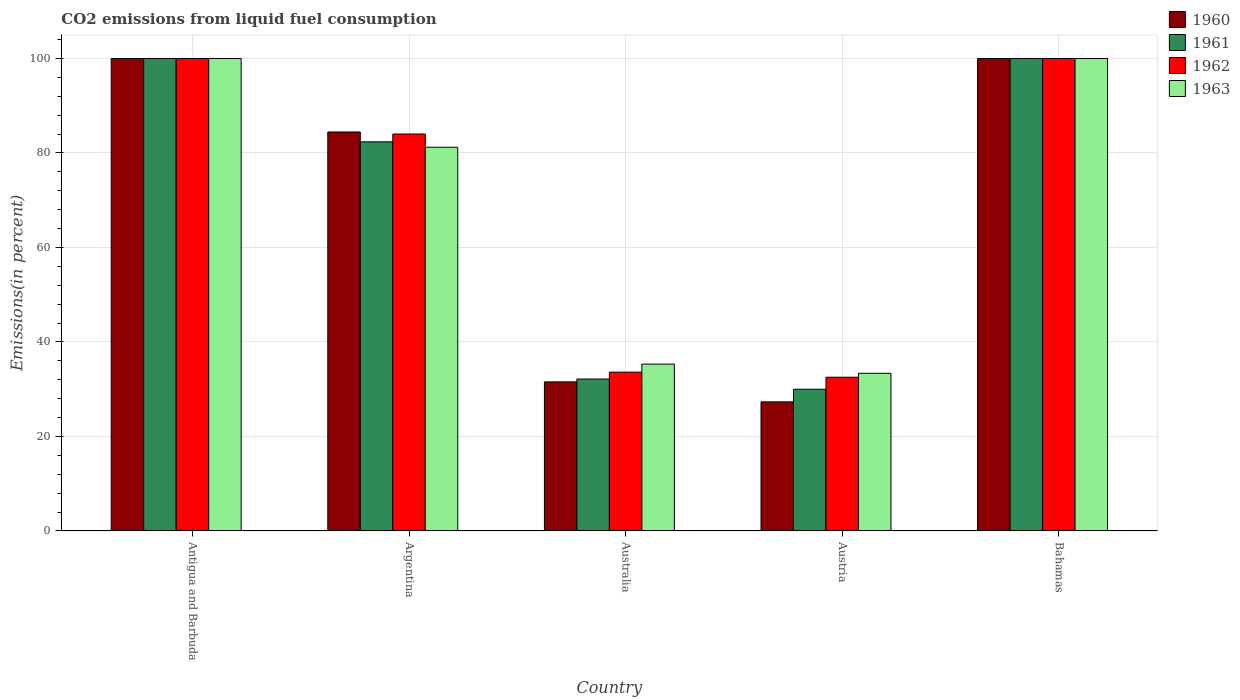Are the number of bars per tick equal to the number of legend labels?
Your answer should be very brief. Yes. Are the number of bars on each tick of the X-axis equal?
Provide a succinct answer. Yes. How many bars are there on the 3rd tick from the left?
Ensure brevity in your answer.  4. What is the total CO2 emitted in 1960 in Argentina?
Your answer should be very brief. 84.45. Across all countries, what is the minimum total CO2 emitted in 1963?
Make the answer very short. 33.38. In which country was the total CO2 emitted in 1961 maximum?
Your response must be concise. Antigua and Barbuda. What is the total total CO2 emitted in 1962 in the graph?
Offer a terse response. 350.18. What is the difference between the total CO2 emitted in 1961 in Antigua and Barbuda and that in Argentina?
Your answer should be compact. 17.63. What is the difference between the total CO2 emitted in 1962 in Australia and the total CO2 emitted in 1960 in Bahamas?
Your response must be concise. -66.38. What is the average total CO2 emitted in 1961 per country?
Keep it short and to the point. 68.91. What is the difference between the total CO2 emitted of/in 1961 and total CO2 emitted of/in 1962 in Argentina?
Provide a short and direct response. -1.65. What is the ratio of the total CO2 emitted in 1963 in Argentina to that in Austria?
Make the answer very short. 2.43. What is the difference between the highest and the second highest total CO2 emitted in 1960?
Your response must be concise. 15.55. What is the difference between the highest and the lowest total CO2 emitted in 1960?
Your response must be concise. 72.67. In how many countries, is the total CO2 emitted in 1960 greater than the average total CO2 emitted in 1960 taken over all countries?
Your answer should be compact. 3. What does the 4th bar from the left in Australia represents?
Your response must be concise. 1963. What does the 2nd bar from the right in Australia represents?
Offer a terse response. 1962. Is it the case that in every country, the sum of the total CO2 emitted in 1960 and total CO2 emitted in 1962 is greater than the total CO2 emitted in 1963?
Offer a terse response. Yes. How many bars are there?
Offer a terse response. 20. Are all the bars in the graph horizontal?
Give a very brief answer. No. What is the difference between two consecutive major ticks on the Y-axis?
Provide a short and direct response. 20. Does the graph contain grids?
Your answer should be very brief. Yes. What is the title of the graph?
Provide a short and direct response. CO2 emissions from liquid fuel consumption. What is the label or title of the Y-axis?
Your response must be concise. Emissions(in percent). What is the Emissions(in percent) in 1960 in Antigua and Barbuda?
Make the answer very short. 100. What is the Emissions(in percent) of 1960 in Argentina?
Keep it short and to the point. 84.45. What is the Emissions(in percent) in 1961 in Argentina?
Your response must be concise. 82.37. What is the Emissions(in percent) in 1962 in Argentina?
Keep it short and to the point. 84.02. What is the Emissions(in percent) of 1963 in Argentina?
Offer a terse response. 81.22. What is the Emissions(in percent) in 1960 in Australia?
Give a very brief answer. 31.56. What is the Emissions(in percent) of 1961 in Australia?
Your response must be concise. 32.16. What is the Emissions(in percent) of 1962 in Australia?
Offer a terse response. 33.62. What is the Emissions(in percent) in 1963 in Australia?
Provide a succinct answer. 35.32. What is the Emissions(in percent) in 1960 in Austria?
Make the answer very short. 27.33. What is the Emissions(in percent) of 1961 in Austria?
Your answer should be very brief. 30. What is the Emissions(in percent) in 1962 in Austria?
Provide a succinct answer. 32.54. What is the Emissions(in percent) of 1963 in Austria?
Your response must be concise. 33.38. What is the Emissions(in percent) of 1960 in Bahamas?
Give a very brief answer. 100. What is the Emissions(in percent) of 1962 in Bahamas?
Make the answer very short. 100. Across all countries, what is the maximum Emissions(in percent) in 1961?
Provide a succinct answer. 100. Across all countries, what is the maximum Emissions(in percent) of 1962?
Offer a very short reply. 100. Across all countries, what is the maximum Emissions(in percent) in 1963?
Your answer should be compact. 100. Across all countries, what is the minimum Emissions(in percent) in 1960?
Keep it short and to the point. 27.33. Across all countries, what is the minimum Emissions(in percent) of 1961?
Ensure brevity in your answer.  30. Across all countries, what is the minimum Emissions(in percent) in 1962?
Offer a very short reply. 32.54. Across all countries, what is the minimum Emissions(in percent) in 1963?
Provide a succinct answer. 33.38. What is the total Emissions(in percent) in 1960 in the graph?
Ensure brevity in your answer.  343.33. What is the total Emissions(in percent) in 1961 in the graph?
Give a very brief answer. 344.54. What is the total Emissions(in percent) in 1962 in the graph?
Ensure brevity in your answer.  350.18. What is the total Emissions(in percent) in 1963 in the graph?
Keep it short and to the point. 349.92. What is the difference between the Emissions(in percent) in 1960 in Antigua and Barbuda and that in Argentina?
Provide a short and direct response. 15.55. What is the difference between the Emissions(in percent) of 1961 in Antigua and Barbuda and that in Argentina?
Your answer should be very brief. 17.63. What is the difference between the Emissions(in percent) of 1962 in Antigua and Barbuda and that in Argentina?
Provide a short and direct response. 15.98. What is the difference between the Emissions(in percent) of 1963 in Antigua and Barbuda and that in Argentina?
Make the answer very short. 18.78. What is the difference between the Emissions(in percent) of 1960 in Antigua and Barbuda and that in Australia?
Provide a succinct answer. 68.44. What is the difference between the Emissions(in percent) of 1961 in Antigua and Barbuda and that in Australia?
Your answer should be very brief. 67.84. What is the difference between the Emissions(in percent) of 1962 in Antigua and Barbuda and that in Australia?
Your answer should be compact. 66.38. What is the difference between the Emissions(in percent) in 1963 in Antigua and Barbuda and that in Australia?
Provide a succinct answer. 64.68. What is the difference between the Emissions(in percent) of 1960 in Antigua and Barbuda and that in Austria?
Offer a very short reply. 72.67. What is the difference between the Emissions(in percent) of 1961 in Antigua and Barbuda and that in Austria?
Offer a terse response. 70. What is the difference between the Emissions(in percent) of 1962 in Antigua and Barbuda and that in Austria?
Your answer should be compact. 67.46. What is the difference between the Emissions(in percent) of 1963 in Antigua and Barbuda and that in Austria?
Your response must be concise. 66.62. What is the difference between the Emissions(in percent) in 1961 in Antigua and Barbuda and that in Bahamas?
Your answer should be very brief. 0. What is the difference between the Emissions(in percent) of 1962 in Antigua and Barbuda and that in Bahamas?
Give a very brief answer. 0. What is the difference between the Emissions(in percent) in 1963 in Antigua and Barbuda and that in Bahamas?
Your response must be concise. 0. What is the difference between the Emissions(in percent) in 1960 in Argentina and that in Australia?
Make the answer very short. 52.89. What is the difference between the Emissions(in percent) of 1961 in Argentina and that in Australia?
Your response must be concise. 50.2. What is the difference between the Emissions(in percent) in 1962 in Argentina and that in Australia?
Provide a succinct answer. 50.4. What is the difference between the Emissions(in percent) of 1963 in Argentina and that in Australia?
Provide a short and direct response. 45.9. What is the difference between the Emissions(in percent) in 1960 in Argentina and that in Austria?
Your response must be concise. 57.12. What is the difference between the Emissions(in percent) of 1961 in Argentina and that in Austria?
Your answer should be very brief. 52.36. What is the difference between the Emissions(in percent) in 1962 in Argentina and that in Austria?
Offer a terse response. 51.48. What is the difference between the Emissions(in percent) of 1963 in Argentina and that in Austria?
Provide a short and direct response. 47.84. What is the difference between the Emissions(in percent) in 1960 in Argentina and that in Bahamas?
Provide a short and direct response. -15.55. What is the difference between the Emissions(in percent) in 1961 in Argentina and that in Bahamas?
Offer a terse response. -17.63. What is the difference between the Emissions(in percent) of 1962 in Argentina and that in Bahamas?
Offer a very short reply. -15.98. What is the difference between the Emissions(in percent) in 1963 in Argentina and that in Bahamas?
Give a very brief answer. -18.78. What is the difference between the Emissions(in percent) in 1960 in Australia and that in Austria?
Offer a terse response. 4.23. What is the difference between the Emissions(in percent) of 1961 in Australia and that in Austria?
Your answer should be very brief. 2.16. What is the difference between the Emissions(in percent) of 1962 in Australia and that in Austria?
Offer a terse response. 1.08. What is the difference between the Emissions(in percent) of 1963 in Australia and that in Austria?
Make the answer very short. 1.95. What is the difference between the Emissions(in percent) in 1960 in Australia and that in Bahamas?
Keep it short and to the point. -68.44. What is the difference between the Emissions(in percent) of 1961 in Australia and that in Bahamas?
Provide a short and direct response. -67.84. What is the difference between the Emissions(in percent) of 1962 in Australia and that in Bahamas?
Offer a terse response. -66.38. What is the difference between the Emissions(in percent) of 1963 in Australia and that in Bahamas?
Provide a succinct answer. -64.68. What is the difference between the Emissions(in percent) in 1960 in Austria and that in Bahamas?
Your response must be concise. -72.67. What is the difference between the Emissions(in percent) of 1961 in Austria and that in Bahamas?
Give a very brief answer. -70. What is the difference between the Emissions(in percent) of 1962 in Austria and that in Bahamas?
Keep it short and to the point. -67.46. What is the difference between the Emissions(in percent) in 1963 in Austria and that in Bahamas?
Provide a short and direct response. -66.62. What is the difference between the Emissions(in percent) in 1960 in Antigua and Barbuda and the Emissions(in percent) in 1961 in Argentina?
Offer a very short reply. 17.63. What is the difference between the Emissions(in percent) in 1960 in Antigua and Barbuda and the Emissions(in percent) in 1962 in Argentina?
Your response must be concise. 15.98. What is the difference between the Emissions(in percent) in 1960 in Antigua and Barbuda and the Emissions(in percent) in 1963 in Argentina?
Your answer should be very brief. 18.78. What is the difference between the Emissions(in percent) in 1961 in Antigua and Barbuda and the Emissions(in percent) in 1962 in Argentina?
Provide a succinct answer. 15.98. What is the difference between the Emissions(in percent) of 1961 in Antigua and Barbuda and the Emissions(in percent) of 1963 in Argentina?
Offer a terse response. 18.78. What is the difference between the Emissions(in percent) in 1962 in Antigua and Barbuda and the Emissions(in percent) in 1963 in Argentina?
Your answer should be very brief. 18.78. What is the difference between the Emissions(in percent) of 1960 in Antigua and Barbuda and the Emissions(in percent) of 1961 in Australia?
Ensure brevity in your answer.  67.84. What is the difference between the Emissions(in percent) in 1960 in Antigua and Barbuda and the Emissions(in percent) in 1962 in Australia?
Offer a terse response. 66.38. What is the difference between the Emissions(in percent) in 1960 in Antigua and Barbuda and the Emissions(in percent) in 1963 in Australia?
Keep it short and to the point. 64.68. What is the difference between the Emissions(in percent) in 1961 in Antigua and Barbuda and the Emissions(in percent) in 1962 in Australia?
Provide a short and direct response. 66.38. What is the difference between the Emissions(in percent) of 1961 in Antigua and Barbuda and the Emissions(in percent) of 1963 in Australia?
Make the answer very short. 64.68. What is the difference between the Emissions(in percent) of 1962 in Antigua and Barbuda and the Emissions(in percent) of 1963 in Australia?
Ensure brevity in your answer.  64.68. What is the difference between the Emissions(in percent) of 1960 in Antigua and Barbuda and the Emissions(in percent) of 1961 in Austria?
Ensure brevity in your answer.  70. What is the difference between the Emissions(in percent) in 1960 in Antigua and Barbuda and the Emissions(in percent) in 1962 in Austria?
Your response must be concise. 67.46. What is the difference between the Emissions(in percent) in 1960 in Antigua and Barbuda and the Emissions(in percent) in 1963 in Austria?
Your answer should be compact. 66.62. What is the difference between the Emissions(in percent) in 1961 in Antigua and Barbuda and the Emissions(in percent) in 1962 in Austria?
Your answer should be very brief. 67.46. What is the difference between the Emissions(in percent) of 1961 in Antigua and Barbuda and the Emissions(in percent) of 1963 in Austria?
Give a very brief answer. 66.62. What is the difference between the Emissions(in percent) of 1962 in Antigua and Barbuda and the Emissions(in percent) of 1963 in Austria?
Offer a very short reply. 66.62. What is the difference between the Emissions(in percent) in 1960 in Antigua and Barbuda and the Emissions(in percent) in 1962 in Bahamas?
Ensure brevity in your answer.  0. What is the difference between the Emissions(in percent) in 1961 in Antigua and Barbuda and the Emissions(in percent) in 1963 in Bahamas?
Keep it short and to the point. 0. What is the difference between the Emissions(in percent) of 1960 in Argentina and the Emissions(in percent) of 1961 in Australia?
Provide a short and direct response. 52.29. What is the difference between the Emissions(in percent) in 1960 in Argentina and the Emissions(in percent) in 1962 in Australia?
Ensure brevity in your answer.  50.83. What is the difference between the Emissions(in percent) of 1960 in Argentina and the Emissions(in percent) of 1963 in Australia?
Offer a terse response. 49.13. What is the difference between the Emissions(in percent) of 1961 in Argentina and the Emissions(in percent) of 1962 in Australia?
Give a very brief answer. 48.75. What is the difference between the Emissions(in percent) of 1961 in Argentina and the Emissions(in percent) of 1963 in Australia?
Make the answer very short. 47.04. What is the difference between the Emissions(in percent) in 1962 in Argentina and the Emissions(in percent) in 1963 in Australia?
Make the answer very short. 48.7. What is the difference between the Emissions(in percent) of 1960 in Argentina and the Emissions(in percent) of 1961 in Austria?
Give a very brief answer. 54.45. What is the difference between the Emissions(in percent) in 1960 in Argentina and the Emissions(in percent) in 1962 in Austria?
Your answer should be compact. 51.91. What is the difference between the Emissions(in percent) of 1960 in Argentina and the Emissions(in percent) of 1963 in Austria?
Your answer should be very brief. 51.07. What is the difference between the Emissions(in percent) of 1961 in Argentina and the Emissions(in percent) of 1962 in Austria?
Your answer should be compact. 49.82. What is the difference between the Emissions(in percent) in 1961 in Argentina and the Emissions(in percent) in 1963 in Austria?
Give a very brief answer. 48.99. What is the difference between the Emissions(in percent) of 1962 in Argentina and the Emissions(in percent) of 1963 in Austria?
Ensure brevity in your answer.  50.64. What is the difference between the Emissions(in percent) in 1960 in Argentina and the Emissions(in percent) in 1961 in Bahamas?
Your response must be concise. -15.55. What is the difference between the Emissions(in percent) of 1960 in Argentina and the Emissions(in percent) of 1962 in Bahamas?
Your answer should be very brief. -15.55. What is the difference between the Emissions(in percent) in 1960 in Argentina and the Emissions(in percent) in 1963 in Bahamas?
Offer a very short reply. -15.55. What is the difference between the Emissions(in percent) of 1961 in Argentina and the Emissions(in percent) of 1962 in Bahamas?
Ensure brevity in your answer.  -17.63. What is the difference between the Emissions(in percent) of 1961 in Argentina and the Emissions(in percent) of 1963 in Bahamas?
Your answer should be very brief. -17.63. What is the difference between the Emissions(in percent) of 1962 in Argentina and the Emissions(in percent) of 1963 in Bahamas?
Your answer should be compact. -15.98. What is the difference between the Emissions(in percent) of 1960 in Australia and the Emissions(in percent) of 1961 in Austria?
Make the answer very short. 1.55. What is the difference between the Emissions(in percent) in 1960 in Australia and the Emissions(in percent) in 1962 in Austria?
Provide a short and direct response. -0.99. What is the difference between the Emissions(in percent) of 1960 in Australia and the Emissions(in percent) of 1963 in Austria?
Your answer should be compact. -1.82. What is the difference between the Emissions(in percent) in 1961 in Australia and the Emissions(in percent) in 1962 in Austria?
Give a very brief answer. -0.38. What is the difference between the Emissions(in percent) in 1961 in Australia and the Emissions(in percent) in 1963 in Austria?
Offer a terse response. -1.21. What is the difference between the Emissions(in percent) of 1962 in Australia and the Emissions(in percent) of 1963 in Austria?
Give a very brief answer. 0.24. What is the difference between the Emissions(in percent) of 1960 in Australia and the Emissions(in percent) of 1961 in Bahamas?
Give a very brief answer. -68.44. What is the difference between the Emissions(in percent) of 1960 in Australia and the Emissions(in percent) of 1962 in Bahamas?
Keep it short and to the point. -68.44. What is the difference between the Emissions(in percent) of 1960 in Australia and the Emissions(in percent) of 1963 in Bahamas?
Offer a terse response. -68.44. What is the difference between the Emissions(in percent) in 1961 in Australia and the Emissions(in percent) in 1962 in Bahamas?
Your answer should be very brief. -67.84. What is the difference between the Emissions(in percent) in 1961 in Australia and the Emissions(in percent) in 1963 in Bahamas?
Make the answer very short. -67.84. What is the difference between the Emissions(in percent) in 1962 in Australia and the Emissions(in percent) in 1963 in Bahamas?
Keep it short and to the point. -66.38. What is the difference between the Emissions(in percent) of 1960 in Austria and the Emissions(in percent) of 1961 in Bahamas?
Your answer should be very brief. -72.67. What is the difference between the Emissions(in percent) in 1960 in Austria and the Emissions(in percent) in 1962 in Bahamas?
Offer a terse response. -72.67. What is the difference between the Emissions(in percent) in 1960 in Austria and the Emissions(in percent) in 1963 in Bahamas?
Offer a terse response. -72.67. What is the difference between the Emissions(in percent) in 1961 in Austria and the Emissions(in percent) in 1962 in Bahamas?
Give a very brief answer. -70. What is the difference between the Emissions(in percent) in 1961 in Austria and the Emissions(in percent) in 1963 in Bahamas?
Offer a very short reply. -70. What is the difference between the Emissions(in percent) in 1962 in Austria and the Emissions(in percent) in 1963 in Bahamas?
Make the answer very short. -67.46. What is the average Emissions(in percent) in 1960 per country?
Provide a succinct answer. 68.67. What is the average Emissions(in percent) in 1961 per country?
Your answer should be very brief. 68.91. What is the average Emissions(in percent) in 1962 per country?
Offer a terse response. 70.04. What is the average Emissions(in percent) of 1963 per country?
Offer a terse response. 69.98. What is the difference between the Emissions(in percent) in 1960 and Emissions(in percent) in 1963 in Antigua and Barbuda?
Your answer should be compact. 0. What is the difference between the Emissions(in percent) in 1961 and Emissions(in percent) in 1963 in Antigua and Barbuda?
Offer a terse response. 0. What is the difference between the Emissions(in percent) in 1960 and Emissions(in percent) in 1961 in Argentina?
Give a very brief answer. 2.08. What is the difference between the Emissions(in percent) in 1960 and Emissions(in percent) in 1962 in Argentina?
Keep it short and to the point. 0.43. What is the difference between the Emissions(in percent) in 1960 and Emissions(in percent) in 1963 in Argentina?
Your answer should be compact. 3.23. What is the difference between the Emissions(in percent) in 1961 and Emissions(in percent) in 1962 in Argentina?
Provide a short and direct response. -1.65. What is the difference between the Emissions(in percent) of 1961 and Emissions(in percent) of 1963 in Argentina?
Your response must be concise. 1.15. What is the difference between the Emissions(in percent) in 1962 and Emissions(in percent) in 1963 in Argentina?
Offer a very short reply. 2.8. What is the difference between the Emissions(in percent) of 1960 and Emissions(in percent) of 1961 in Australia?
Provide a succinct answer. -0.61. What is the difference between the Emissions(in percent) of 1960 and Emissions(in percent) of 1962 in Australia?
Offer a very short reply. -2.07. What is the difference between the Emissions(in percent) of 1960 and Emissions(in percent) of 1963 in Australia?
Your answer should be very brief. -3.77. What is the difference between the Emissions(in percent) in 1961 and Emissions(in percent) in 1962 in Australia?
Offer a very short reply. -1.46. What is the difference between the Emissions(in percent) of 1961 and Emissions(in percent) of 1963 in Australia?
Your response must be concise. -3.16. What is the difference between the Emissions(in percent) of 1962 and Emissions(in percent) of 1963 in Australia?
Your response must be concise. -1.7. What is the difference between the Emissions(in percent) of 1960 and Emissions(in percent) of 1961 in Austria?
Your answer should be compact. -2.67. What is the difference between the Emissions(in percent) in 1960 and Emissions(in percent) in 1962 in Austria?
Give a very brief answer. -5.21. What is the difference between the Emissions(in percent) of 1960 and Emissions(in percent) of 1963 in Austria?
Your answer should be compact. -6.05. What is the difference between the Emissions(in percent) in 1961 and Emissions(in percent) in 1962 in Austria?
Provide a short and direct response. -2.54. What is the difference between the Emissions(in percent) of 1961 and Emissions(in percent) of 1963 in Austria?
Your response must be concise. -3.37. What is the difference between the Emissions(in percent) in 1962 and Emissions(in percent) in 1963 in Austria?
Ensure brevity in your answer.  -0.83. What is the difference between the Emissions(in percent) of 1960 and Emissions(in percent) of 1961 in Bahamas?
Your answer should be compact. 0. What is the difference between the Emissions(in percent) of 1961 and Emissions(in percent) of 1962 in Bahamas?
Keep it short and to the point. 0. What is the ratio of the Emissions(in percent) of 1960 in Antigua and Barbuda to that in Argentina?
Make the answer very short. 1.18. What is the ratio of the Emissions(in percent) in 1961 in Antigua and Barbuda to that in Argentina?
Make the answer very short. 1.21. What is the ratio of the Emissions(in percent) in 1962 in Antigua and Barbuda to that in Argentina?
Offer a very short reply. 1.19. What is the ratio of the Emissions(in percent) in 1963 in Antigua and Barbuda to that in Argentina?
Provide a succinct answer. 1.23. What is the ratio of the Emissions(in percent) of 1960 in Antigua and Barbuda to that in Australia?
Offer a very short reply. 3.17. What is the ratio of the Emissions(in percent) of 1961 in Antigua and Barbuda to that in Australia?
Your answer should be compact. 3.11. What is the ratio of the Emissions(in percent) of 1962 in Antigua and Barbuda to that in Australia?
Provide a succinct answer. 2.97. What is the ratio of the Emissions(in percent) in 1963 in Antigua and Barbuda to that in Australia?
Offer a very short reply. 2.83. What is the ratio of the Emissions(in percent) of 1960 in Antigua and Barbuda to that in Austria?
Provide a succinct answer. 3.66. What is the ratio of the Emissions(in percent) of 1961 in Antigua and Barbuda to that in Austria?
Offer a very short reply. 3.33. What is the ratio of the Emissions(in percent) of 1962 in Antigua and Barbuda to that in Austria?
Your answer should be very brief. 3.07. What is the ratio of the Emissions(in percent) in 1963 in Antigua and Barbuda to that in Austria?
Offer a very short reply. 3. What is the ratio of the Emissions(in percent) of 1960 in Argentina to that in Australia?
Make the answer very short. 2.68. What is the ratio of the Emissions(in percent) in 1961 in Argentina to that in Australia?
Offer a very short reply. 2.56. What is the ratio of the Emissions(in percent) in 1962 in Argentina to that in Australia?
Your answer should be very brief. 2.5. What is the ratio of the Emissions(in percent) of 1963 in Argentina to that in Australia?
Make the answer very short. 2.3. What is the ratio of the Emissions(in percent) in 1960 in Argentina to that in Austria?
Provide a short and direct response. 3.09. What is the ratio of the Emissions(in percent) in 1961 in Argentina to that in Austria?
Provide a short and direct response. 2.75. What is the ratio of the Emissions(in percent) in 1962 in Argentina to that in Austria?
Offer a very short reply. 2.58. What is the ratio of the Emissions(in percent) in 1963 in Argentina to that in Austria?
Your answer should be compact. 2.43. What is the ratio of the Emissions(in percent) of 1960 in Argentina to that in Bahamas?
Offer a terse response. 0.84. What is the ratio of the Emissions(in percent) in 1961 in Argentina to that in Bahamas?
Your response must be concise. 0.82. What is the ratio of the Emissions(in percent) of 1962 in Argentina to that in Bahamas?
Provide a short and direct response. 0.84. What is the ratio of the Emissions(in percent) in 1963 in Argentina to that in Bahamas?
Give a very brief answer. 0.81. What is the ratio of the Emissions(in percent) in 1960 in Australia to that in Austria?
Provide a short and direct response. 1.15. What is the ratio of the Emissions(in percent) of 1961 in Australia to that in Austria?
Ensure brevity in your answer.  1.07. What is the ratio of the Emissions(in percent) of 1962 in Australia to that in Austria?
Your answer should be very brief. 1.03. What is the ratio of the Emissions(in percent) in 1963 in Australia to that in Austria?
Ensure brevity in your answer.  1.06. What is the ratio of the Emissions(in percent) of 1960 in Australia to that in Bahamas?
Offer a very short reply. 0.32. What is the ratio of the Emissions(in percent) in 1961 in Australia to that in Bahamas?
Keep it short and to the point. 0.32. What is the ratio of the Emissions(in percent) in 1962 in Australia to that in Bahamas?
Your answer should be compact. 0.34. What is the ratio of the Emissions(in percent) in 1963 in Australia to that in Bahamas?
Ensure brevity in your answer.  0.35. What is the ratio of the Emissions(in percent) in 1960 in Austria to that in Bahamas?
Offer a terse response. 0.27. What is the ratio of the Emissions(in percent) of 1962 in Austria to that in Bahamas?
Offer a terse response. 0.33. What is the ratio of the Emissions(in percent) in 1963 in Austria to that in Bahamas?
Offer a very short reply. 0.33. What is the difference between the highest and the second highest Emissions(in percent) of 1960?
Offer a terse response. 0. What is the difference between the highest and the second highest Emissions(in percent) in 1962?
Ensure brevity in your answer.  0. What is the difference between the highest and the second highest Emissions(in percent) of 1963?
Your answer should be very brief. 0. What is the difference between the highest and the lowest Emissions(in percent) of 1960?
Ensure brevity in your answer.  72.67. What is the difference between the highest and the lowest Emissions(in percent) in 1961?
Offer a very short reply. 70. What is the difference between the highest and the lowest Emissions(in percent) of 1962?
Provide a succinct answer. 67.46. What is the difference between the highest and the lowest Emissions(in percent) in 1963?
Your answer should be compact. 66.62. 